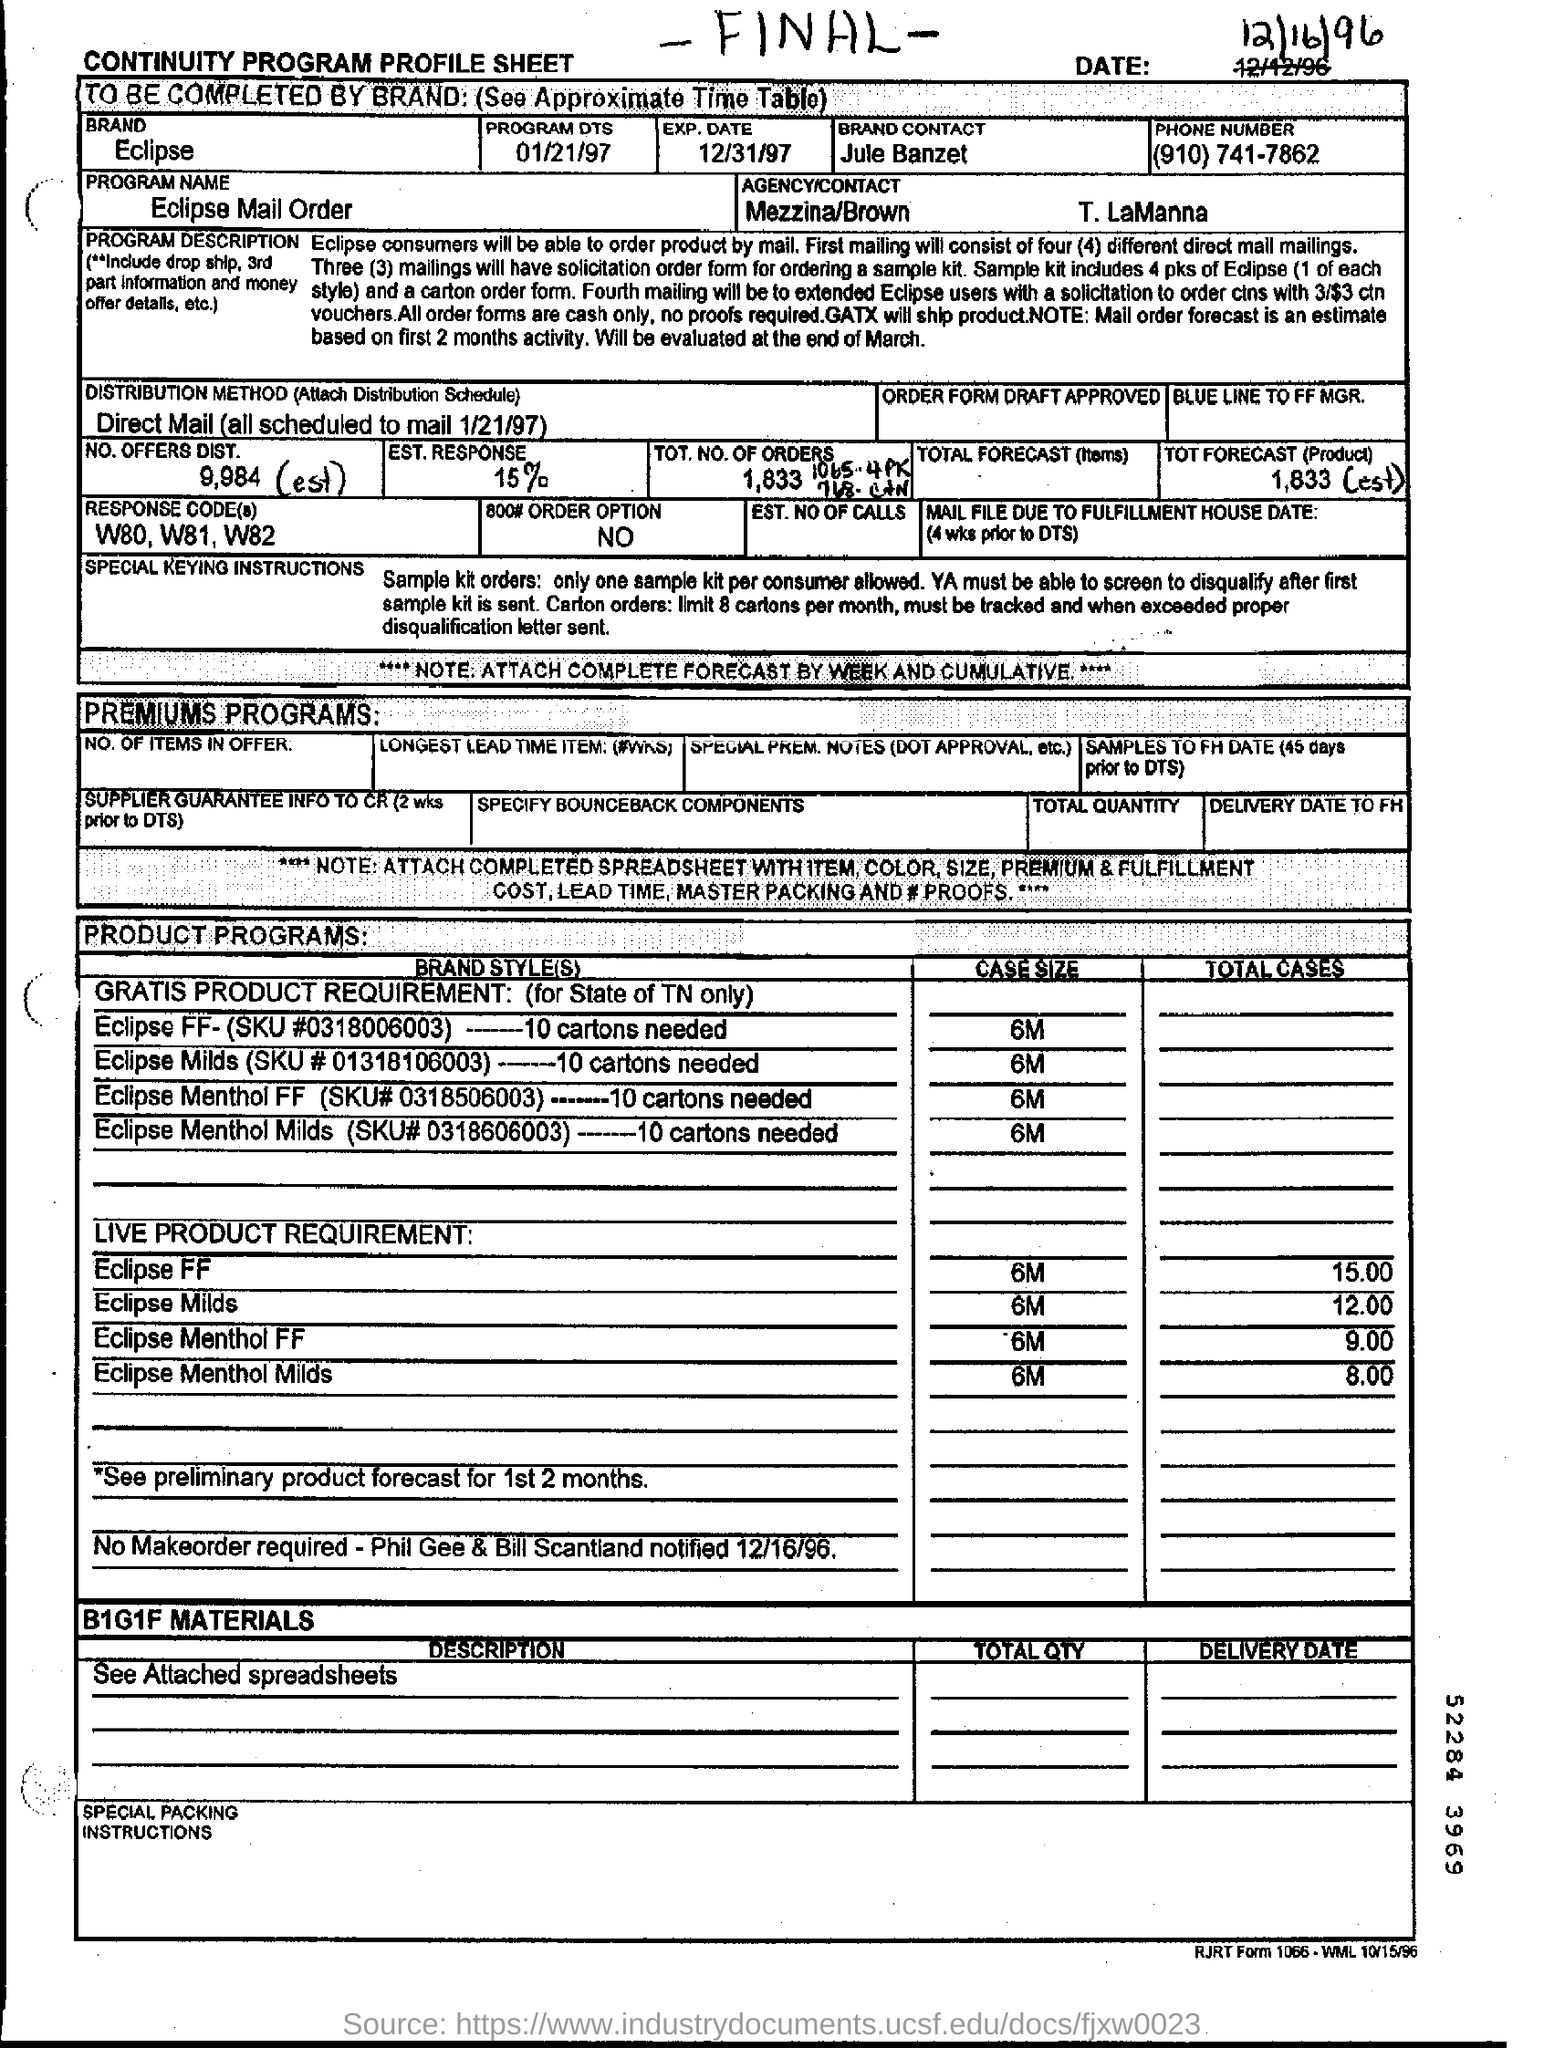List a handful of essential elements in this visual. The program designated as PROGRAM NAME is Eclipse Mail Order... The SKU number of Eclipse Menthol FF is 0318506003. It is necessary to purchase 10 cartons of Eclipse FF. 